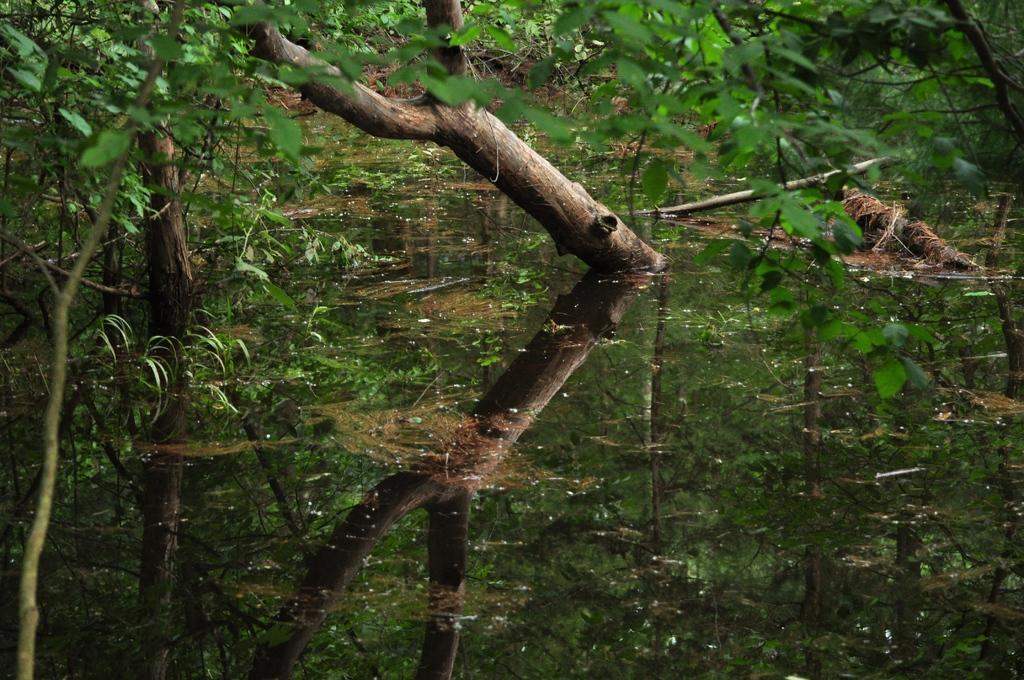Can you describe this image briefly? In this image I can see the water. In the background I can see few trees in green color. 